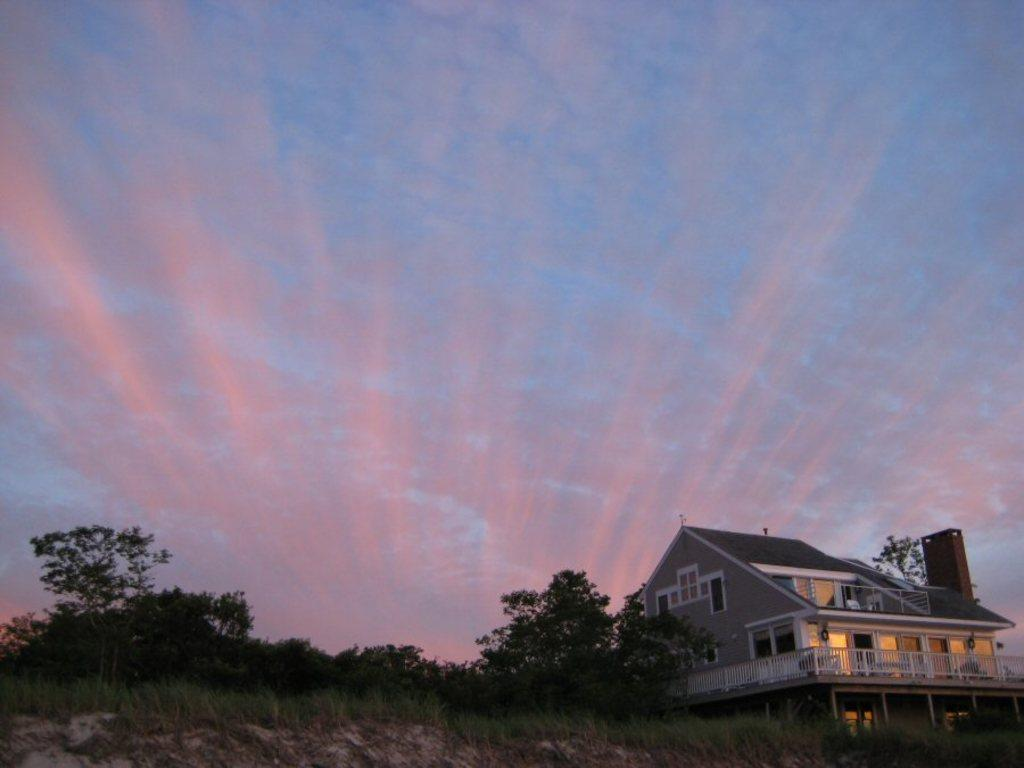What type of vegetation can be seen in the image? There are trees in the image. What is on the ground in the image? There is grass on the ground in the image. Where is the building located in the image? The building is on the right side of the image. What features does the building have? The building has windows, railings, and doors. What is visible in the background of the image? The sky is visible in the background of the image. What can be seen in the sky? There are clouds in the sky. What type of fire can be seen burning in the image? There is no fire present in the image. How does the wind affect the trees in the image? The image does not show any wind or its effects on the trees. 